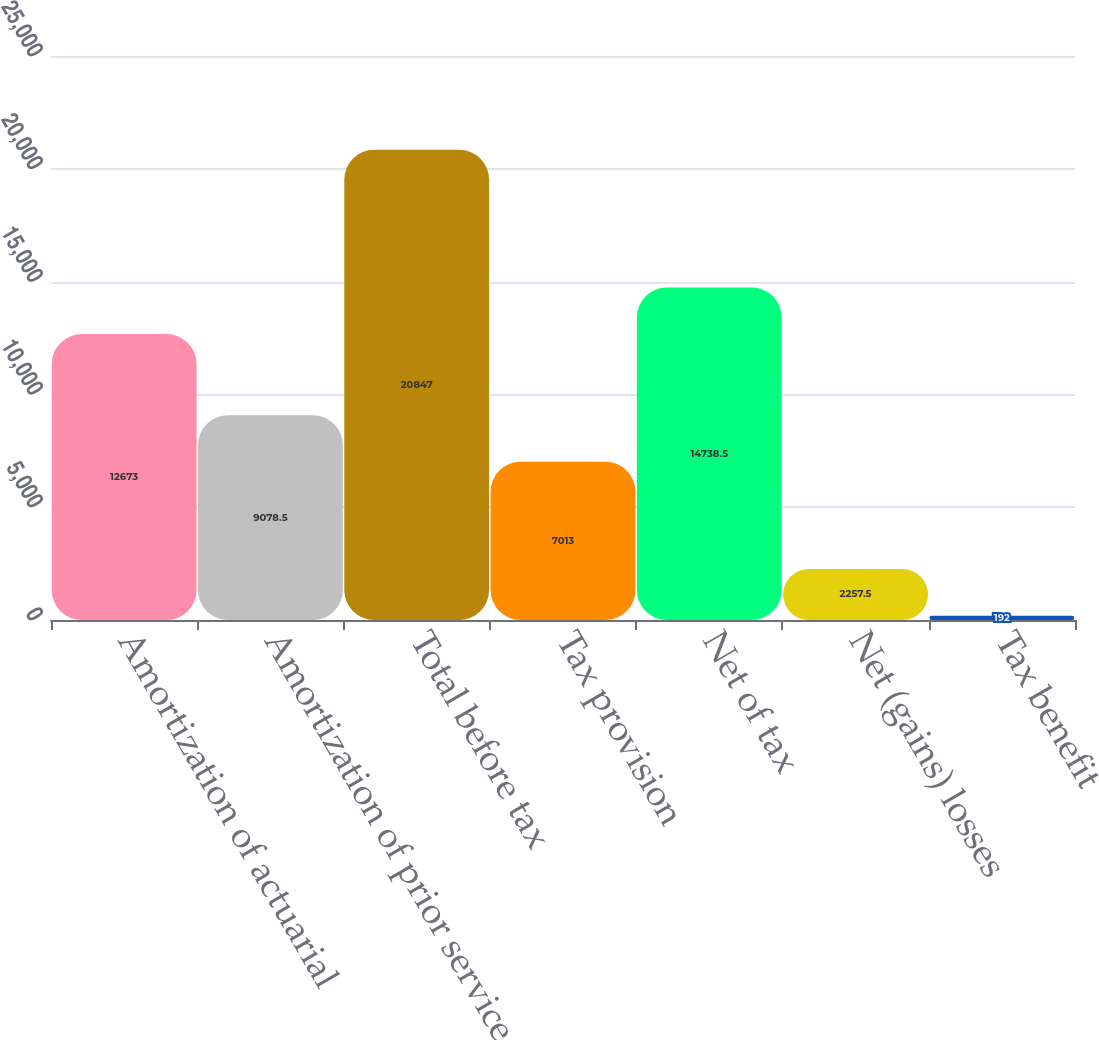Convert chart to OTSL. <chart><loc_0><loc_0><loc_500><loc_500><bar_chart><fcel>Amortization of actuarial<fcel>Amortization of prior service<fcel>Total before tax<fcel>Tax provision<fcel>Net of tax<fcel>Net (gains) losses<fcel>Tax benefit<nl><fcel>12673<fcel>9078.5<fcel>20847<fcel>7013<fcel>14738.5<fcel>2257.5<fcel>192<nl></chart> 